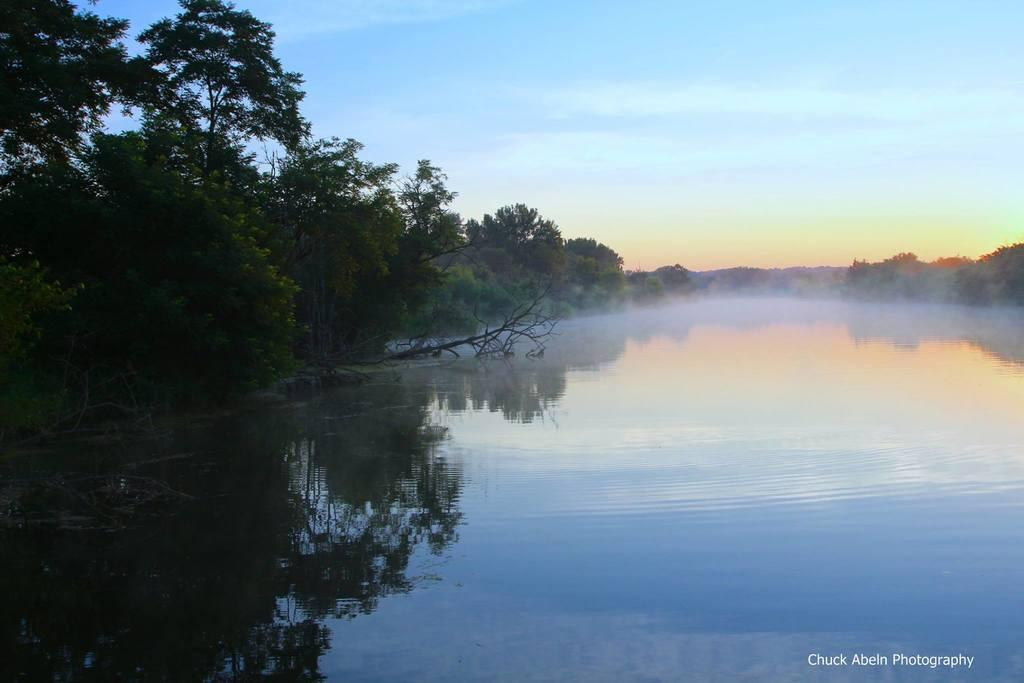What is the main feature in the center of the image? There is a lake in the center of the image. What can be seen on the left side of the image? There are trees on the left side of the image. Are there any trees visible in the background of the image? Yes, there are trees in the background of the image. How would you describe the sky in the image? The sky is cloudy in the image. What type of respect is being shown by the bridge in the image? There is no bridge present in the image, so the question of respect being shown by a bridge is not applicable. 